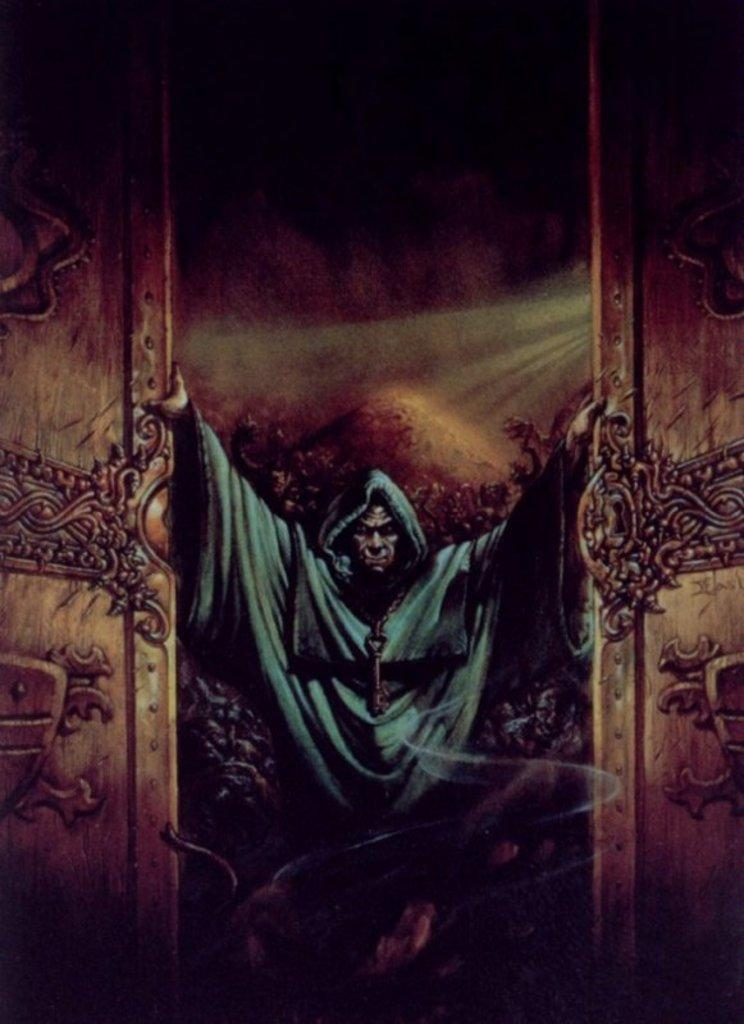What is the main subject in the center of the image? There is a poster in the center of the image. How many pizzas are being burned in the image? There are no pizzas present in the image, and therefore no burning is taking place. 